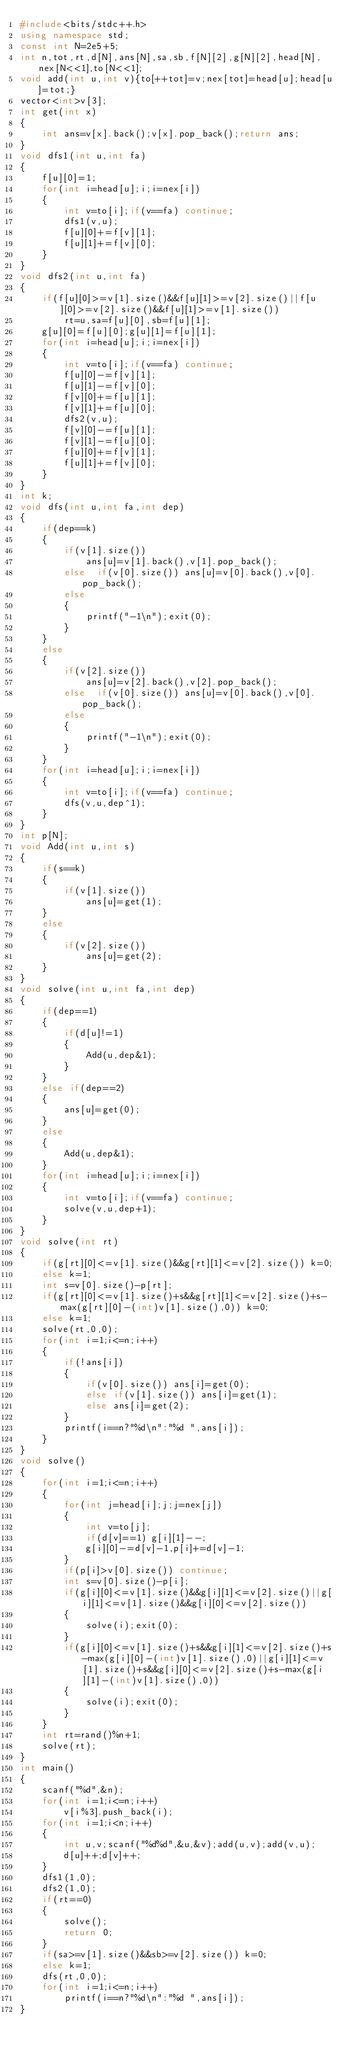<code> <loc_0><loc_0><loc_500><loc_500><_C++_>#include<bits/stdc++.h>
using namespace std;
const int N=2e5+5;
int n,tot,rt,d[N],ans[N],sa,sb,f[N][2],g[N][2],head[N],nex[N<<1],to[N<<1];
void add(int u,int v){to[++tot]=v;nex[tot]=head[u];head[u]=tot;}
vector<int>v[3];
int get(int x)
{
    int ans=v[x].back();v[x].pop_back();return ans;
}
void dfs1(int u,int fa)
{
    f[u][0]=1;
    for(int i=head[u];i;i=nex[i])
    {
        int v=to[i];if(v==fa) continue;
        dfs1(v,u);
        f[u][0]+=f[v][1];
        f[u][1]+=f[v][0];
    }
}
void dfs2(int u,int fa)
{
    if(f[u][0]>=v[1].size()&&f[u][1]>=v[2].size()||f[u][0]>=v[2].size()&&f[u][1]>=v[1].size())
        rt=u,sa=f[u][0],sb=f[u][1];
    g[u][0]=f[u][0];g[u][1]=f[u][1];
    for(int i=head[u];i;i=nex[i])
    {
        int v=to[i];if(v==fa) continue;
        f[u][0]-=f[v][1];
        f[u][1]-=f[v][0];
        f[v][0]+=f[u][1];
        f[v][1]+=f[u][0];
        dfs2(v,u);
        f[v][0]-=f[u][1];
        f[v][1]-=f[u][0];
        f[u][0]+=f[v][1];
        f[u][1]+=f[v][0];
    }
}
int k;
void dfs(int u,int fa,int dep)
{
    if(dep==k)
    {
        if(v[1].size())
            ans[u]=v[1].back(),v[1].pop_back();
        else  if(v[0].size()) ans[u]=v[0].back(),v[0].pop_back();
        else
        {
            printf("-1\n");exit(0);
        }
    }
    else
    {
        if(v[2].size())
            ans[u]=v[2].back(),v[2].pop_back();
        else  if(v[0].size()) ans[u]=v[0].back(),v[0].pop_back();
        else
        {
            printf("-1\n");exit(0);
        }
    }
    for(int i=head[u];i;i=nex[i])
    {
        int v=to[i];if(v==fa) continue;
        dfs(v,u,dep^1);
    }
}
int p[N];
void Add(int u,int s)
{
    if(s==k)
    {
        if(v[1].size())
            ans[u]=get(1);
    }
    else
    {
        if(v[2].size())
            ans[u]=get(2);
    }
}
void solve(int u,int fa,int dep)
{
    if(dep==1)
    {
        if(d[u]!=1)
        {
            Add(u,dep&1);
        }
    }
    else if(dep==2)
    {
        ans[u]=get(0);
    }
    else
    {
        Add(u,dep&1);
    }
    for(int i=head[u];i;i=nex[i])
    {
        int v=to[i];if(v==fa) continue;
        solve(v,u,dep+1);
    }
}
void solve(int rt)
{
    if(g[rt][0]<=v[1].size()&&g[rt][1]<=v[2].size()) k=0;
    else k=1;
    int s=v[0].size()-p[rt];
    if(g[rt][0]<=v[1].size()+s&&g[rt][1]<=v[2].size()+s-max(g[rt][0]-(int)v[1].size(),0)) k=0;
    else k=1;
    solve(rt,0,0);
    for(int i=1;i<=n;i++)
    {
        if(!ans[i])
        {
            if(v[0].size()) ans[i]=get(0);
            else if(v[1].size()) ans[i]=get(1);
            else ans[i]=get(2);
        }
        printf(i==n?"%d\n":"%d ",ans[i]);
    }
}
void solve()
{
    for(int i=1;i<=n;i++)
    {
        for(int j=head[i];j;j=nex[j])
        {
            int v=to[j];
            if(d[v]==1) g[i][1]--;
            g[i][0]-=d[v]-1,p[i]+=d[v]-1;
        }
        if(p[i]>v[0].size()) continue;
        int s=v[0].size()-p[i];
        if(g[i][0]<=v[1].size()&&g[i][1]<=v[2].size()||g[i][1]<=v[1].size()&&g[i][0]<=v[2].size())
        {
            solve(i);exit(0);
        }
        if(g[i][0]<=v[1].size()+s&&g[i][1]<=v[2].size()+s-max(g[i][0]-(int)v[1].size(),0)||g[i][1]<=v[1].size()+s&&g[i][0]<=v[2].size()+s-max(g[i][1]-(int)v[1].size(),0))
        {
            solve(i);exit(0);
        }
    }
    int rt=rand()%n+1;
    solve(rt);
}
int main()
{
    scanf("%d",&n);
    for(int i=1;i<=n;i++)
        v[i%3].push_back(i);
    for(int i=1;i<n;i++)
    {
        int u,v;scanf("%d%d",&u,&v);add(u,v);add(v,u);
        d[u]++;d[v]++;
    }
    dfs1(1,0);
    dfs2(1,0);
    if(rt==0)
    {
        solve();
        return 0;
    }
    if(sa>=v[1].size()&&sb>=v[2].size()) k=0;
    else k=1;
    dfs(rt,0,0);
    for(int i=1;i<=n;i++)
        printf(i==n?"%d\n":"%d ",ans[i]);
}
</code> 